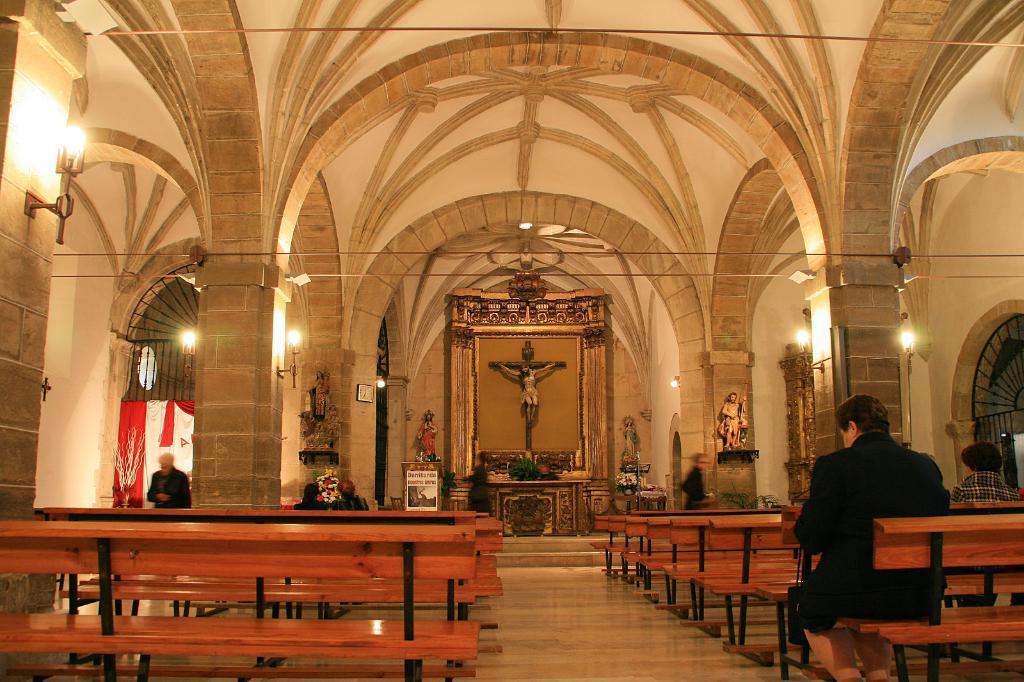Please provide a concise description of this image. In this image, I can see few people sitting and two people standing. These are the wooden benches. I can see the sculptures. These are the lamps, which are attached to the walls. I think this picture was taken inside the church. This is the floor. 